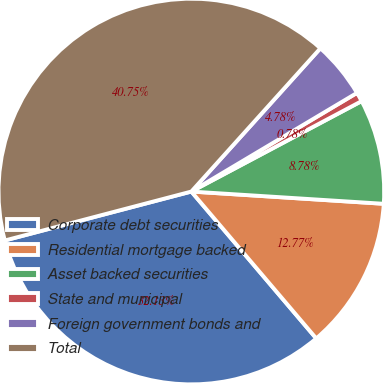<chart> <loc_0><loc_0><loc_500><loc_500><pie_chart><fcel>Corporate debt securities<fcel>Residential mortgage backed<fcel>Asset backed securities<fcel>State and municipal<fcel>Foreign government bonds and<fcel>Total<nl><fcel>32.13%<fcel>12.77%<fcel>8.78%<fcel>0.78%<fcel>4.78%<fcel>40.75%<nl></chart> 